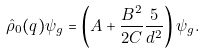<formula> <loc_0><loc_0><loc_500><loc_500>\hat { \rho } _ { 0 } ( q ) \psi _ { g } = \left ( A + \frac { B ^ { 2 } } { 2 C } \frac { 5 } { d ^ { 2 } } \right ) \psi _ { g } .</formula> 